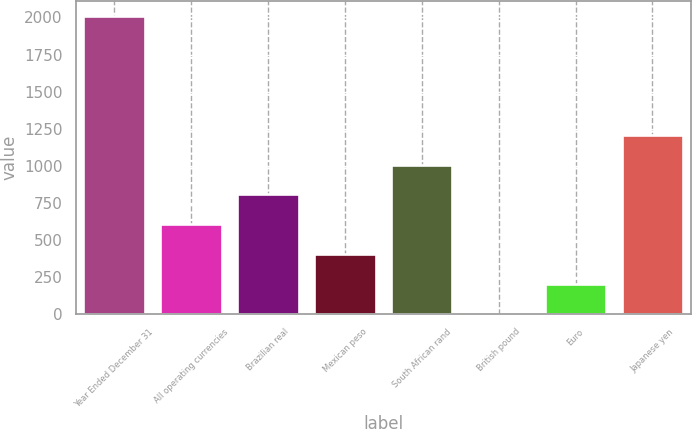Convert chart. <chart><loc_0><loc_0><loc_500><loc_500><bar_chart><fcel>Year Ended December 31<fcel>All operating currencies<fcel>Brazilian real<fcel>Mexican peso<fcel>South African rand<fcel>British pound<fcel>Euro<fcel>Japanese yen<nl><fcel>2013<fcel>605.3<fcel>806.4<fcel>404.2<fcel>1007.5<fcel>2<fcel>203.1<fcel>1208.6<nl></chart> 